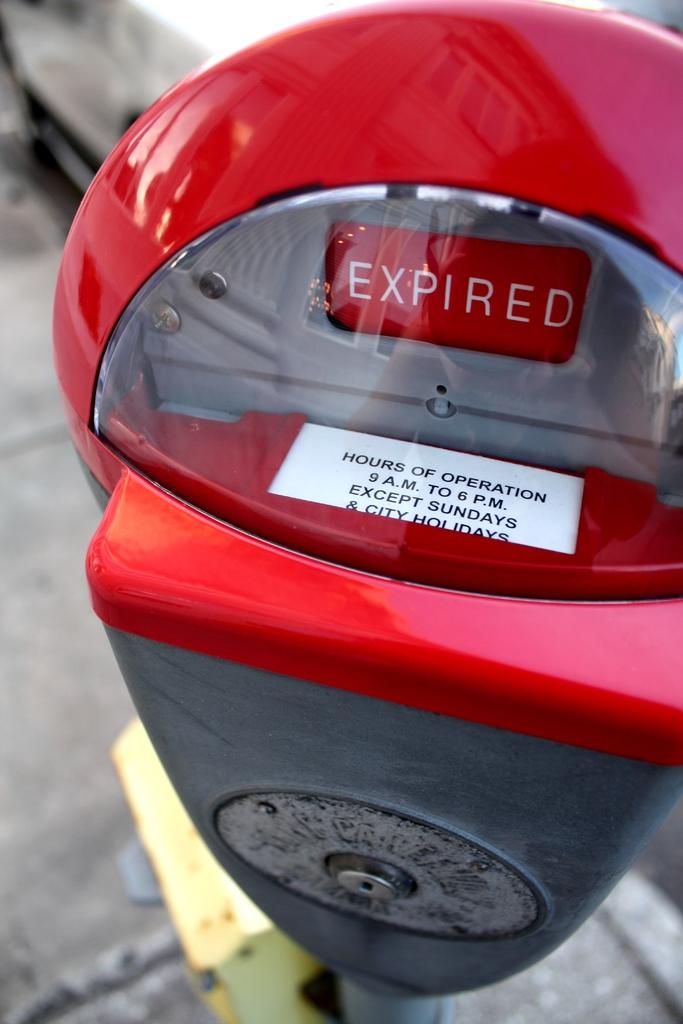What are the hours of operation?
Provide a short and direct response. 9am to 6pm. 